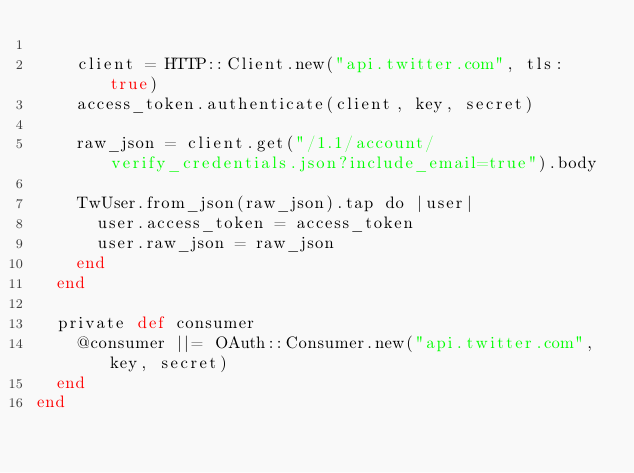Convert code to text. <code><loc_0><loc_0><loc_500><loc_500><_Crystal_>
    client = HTTP::Client.new("api.twitter.com", tls: true)
    access_token.authenticate(client, key, secret)

    raw_json = client.get("/1.1/account/verify_credentials.json?include_email=true").body

    TwUser.from_json(raw_json).tap do |user|
      user.access_token = access_token
      user.raw_json = raw_json
    end
  end

  private def consumer
    @consumer ||= OAuth::Consumer.new("api.twitter.com", key, secret)
  end
end
</code> 